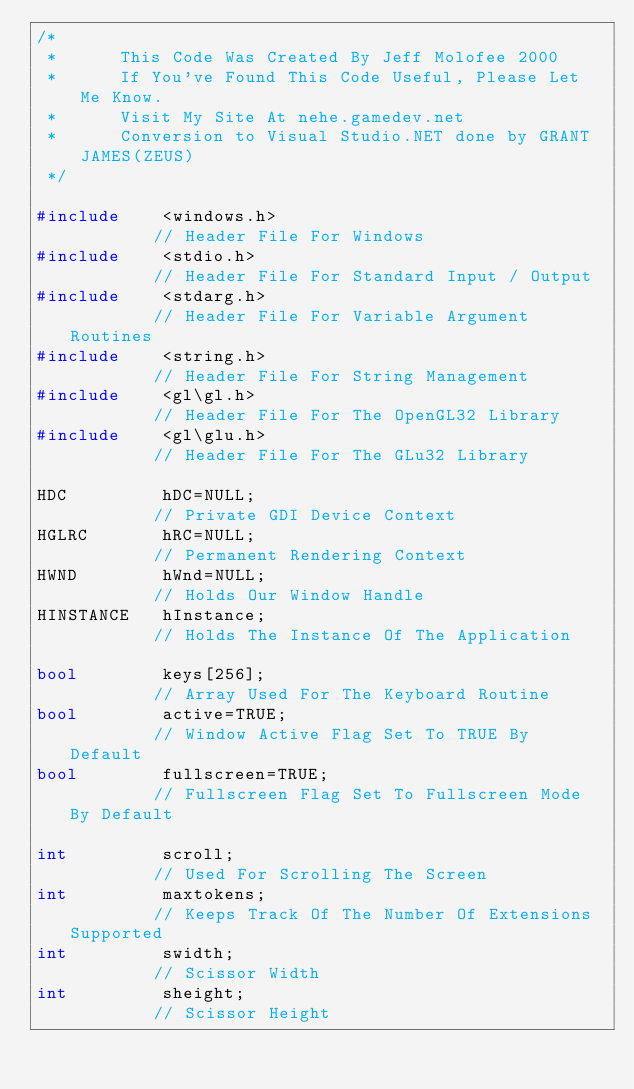Convert code to text. <code><loc_0><loc_0><loc_500><loc_500><_C++_>/*
 *		This Code Was Created By Jeff Molofee 2000
 *		If You've Found This Code Useful, Please Let Me Know.
 *		Visit My Site At nehe.gamedev.net
 *		Conversion to Visual Studio.NET done by GRANT JAMES(ZEUS)
 */

#include	<windows.h>										// Header File For Windows
#include	<stdio.h>										// Header File For Standard Input / Output
#include	<stdarg.h>										// Header File For Variable Argument Routines
#include	<string.h>										// Header File For String Management
#include	<gl\gl.h>										// Header File For The OpenGL32 Library
#include	<gl\glu.h>										// Header File For The GLu32 Library

HDC			hDC=NULL;										// Private GDI Device Context
HGLRC		hRC=NULL;										// Permanent Rendering Context
HWND		hWnd=NULL;										// Holds Our Window Handle
HINSTANCE	hInstance;										// Holds The Instance Of The Application

bool		keys[256];										// Array Used For The Keyboard Routine
bool		active=TRUE;									// Window Active Flag Set To TRUE By Default
bool		fullscreen=TRUE;								// Fullscreen Flag Set To Fullscreen Mode By Default

int			scroll;											// Used For Scrolling The Screen
int			maxtokens;										// Keeps Track Of The Number Of Extensions Supported
int			swidth;											// Scissor Width
int			sheight;										// Scissor Height
</code> 